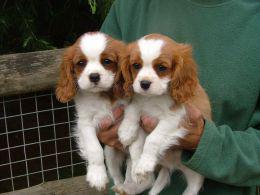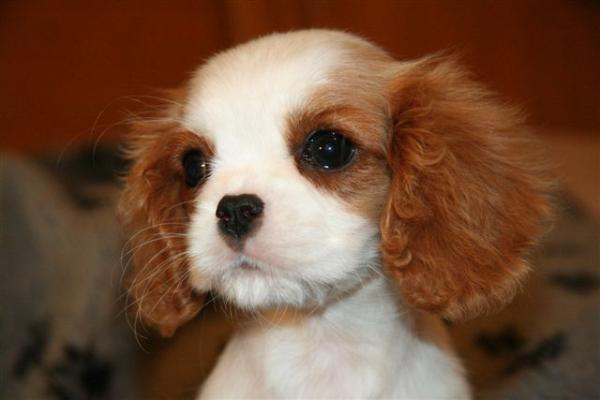The first image is the image on the left, the second image is the image on the right. For the images shown, is this caption "A dog is lying on the floor with its head up in the left image." true? Answer yes or no. No. The first image is the image on the left, the second image is the image on the right. Given the left and right images, does the statement "An image shows one brown and white dog posed on a brownish tile floor." hold true? Answer yes or no. No. 